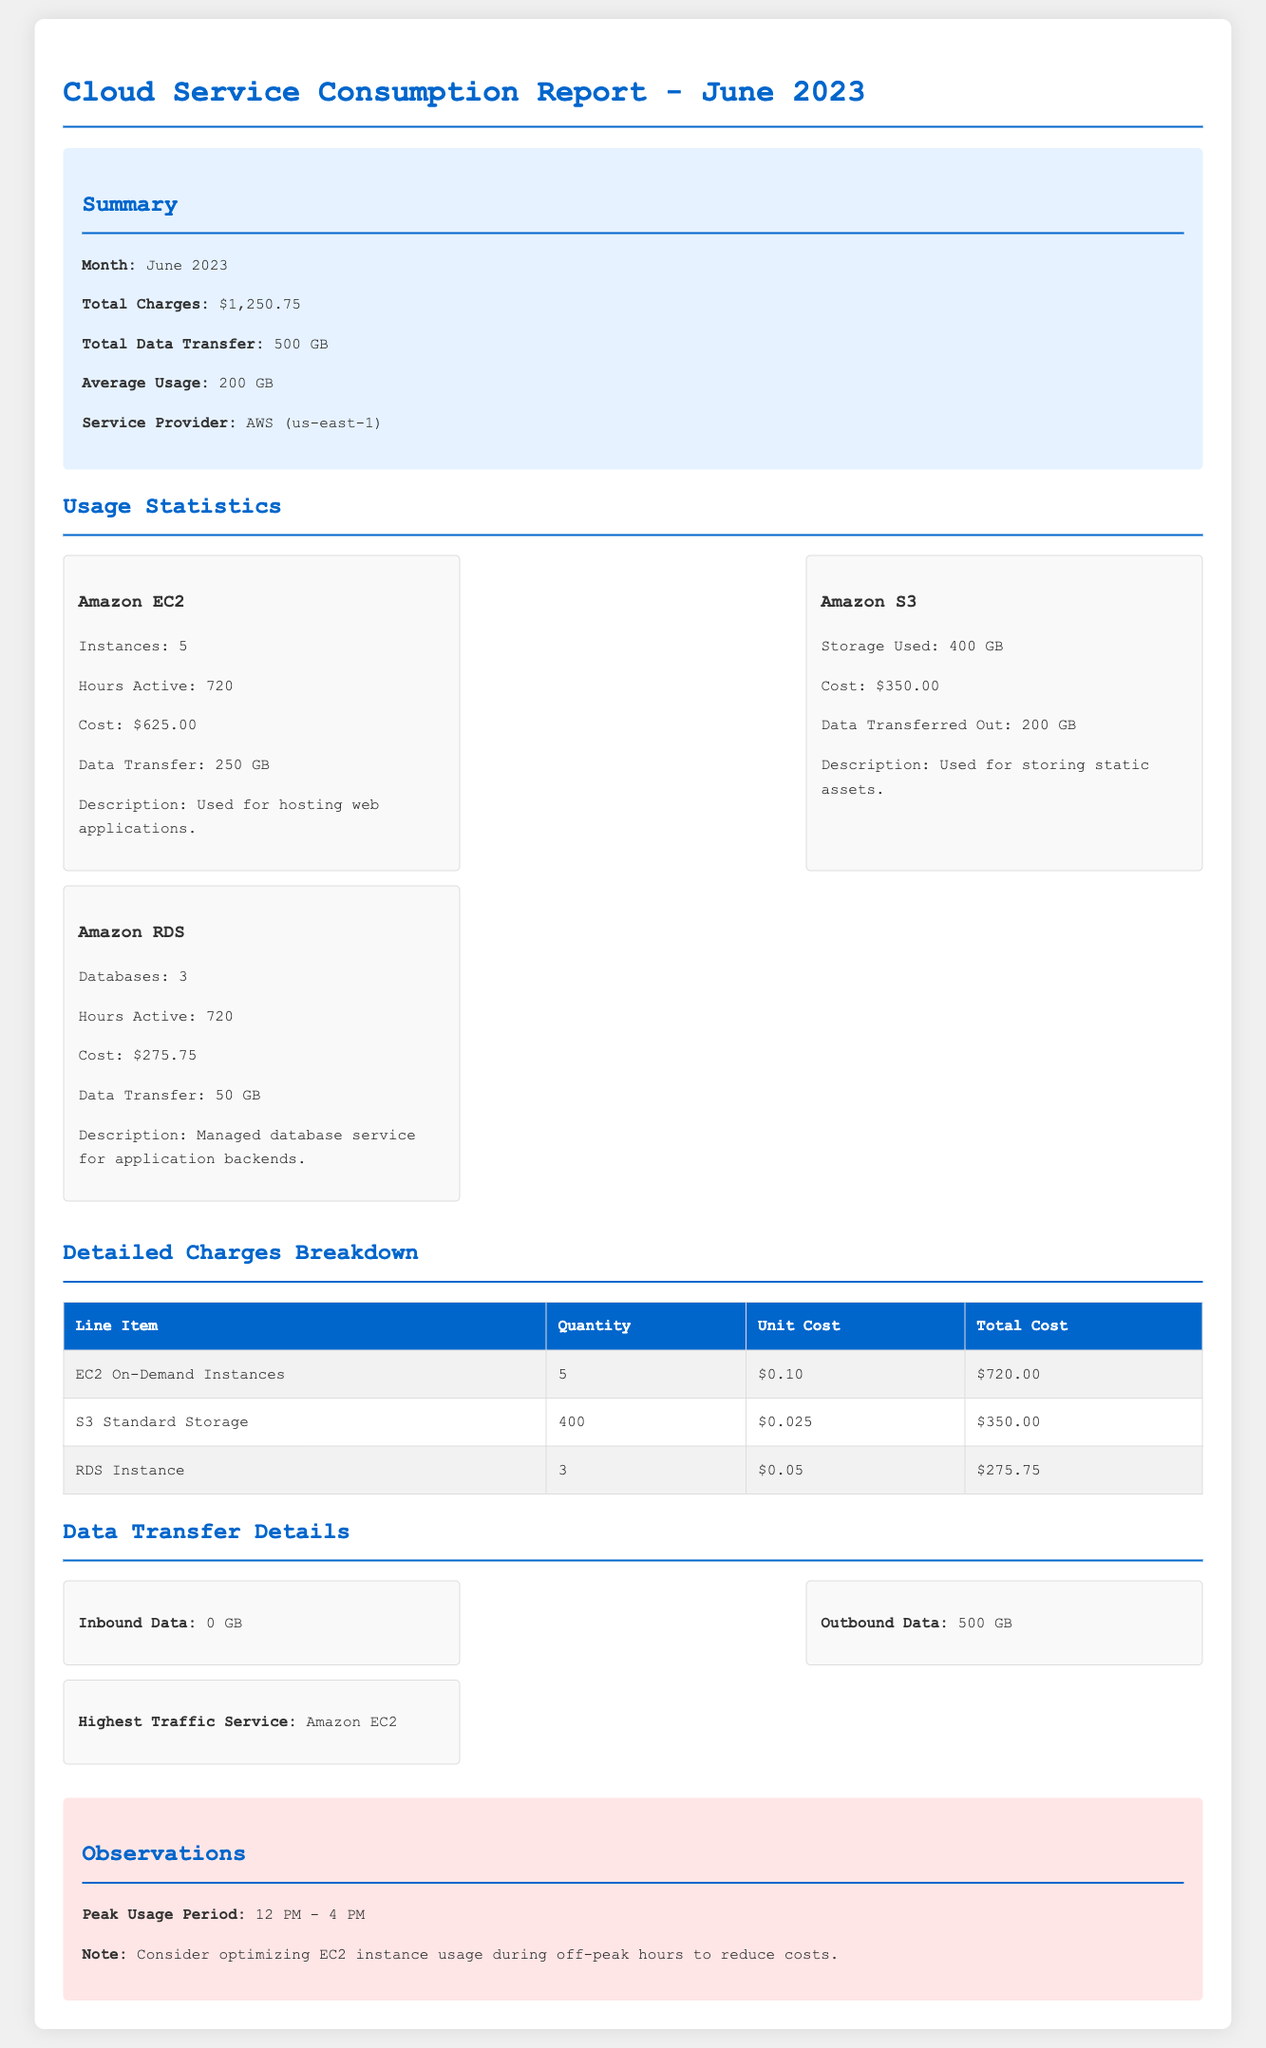What is the total charge for June 2023? The total charge is stated in the summary section of the document.
Answer: $1,250.75 How many hours were Amazon EC2 instances active? The number of active hours for Amazon EC2 is provided in the usage statistics section.
Answer: 720 What is the total data transfer for June 2023? The total data transfer is mentioned in the summary section of the document.
Answer: 500 GB What is the cost associated with Amazon S3? The cost for Amazon S3 is detailed in the usage statistics section.
Answer: $350.00 Which service had the highest traffic? The document specifies which service had the highest traffic in the data transfer details section.
Answer: Amazon EC2 What was the peak usage period? The peak usage period is noted in the observations section of the document.
Answer: 12 PM - 4 PM How many Amazon RDS databases were in use? The number of databases is stated in the usage statistics section.
Answer: 3 What is the unit cost for RDS Instance? The unit cost for RDS Instance is provided in the detailed charges breakdown table.
Answer: $0.05 